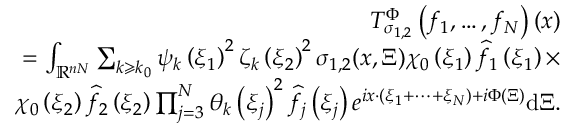Convert formula to latex. <formula><loc_0><loc_0><loc_500><loc_500>\begin{array} { r } { T _ { \sigma _ { 1 , 2 } } ^ { \Phi } \left ( f _ { 1 } , \dots , f _ { N } \right ) ( x ) } \\ { = \int _ { \mathbb { R } ^ { n N } } \sum _ { k \geqslant k _ { 0 } } \psi _ { k } \left ( \xi _ { 1 } \right ) ^ { 2 } { \zeta } _ { k } \left ( \xi _ { 2 } \right ) ^ { 2 } \sigma _ { 1 , 2 } ( x , \Xi ) \chi _ { 0 } \left ( \xi _ { 1 } \right ) \widehat { f } _ { 1 } \left ( \xi _ { 1 } \right ) \times } \\ { \chi _ { 0 } \left ( \xi _ { 2 } \right ) \widehat { f } _ { 2 } \left ( \xi _ { 2 } \right ) \prod _ { j = 3 } ^ { N } \theta _ { k } \left ( \xi _ { j } \right ) ^ { 2 } \widehat { f } _ { j } \left ( \xi _ { j } \right ) e ^ { i x \cdot \left ( \xi _ { 1 } + \cdots + \xi _ { N } \right ) + i \Phi ( \Xi ) } d \Xi . } \end{array}</formula> 